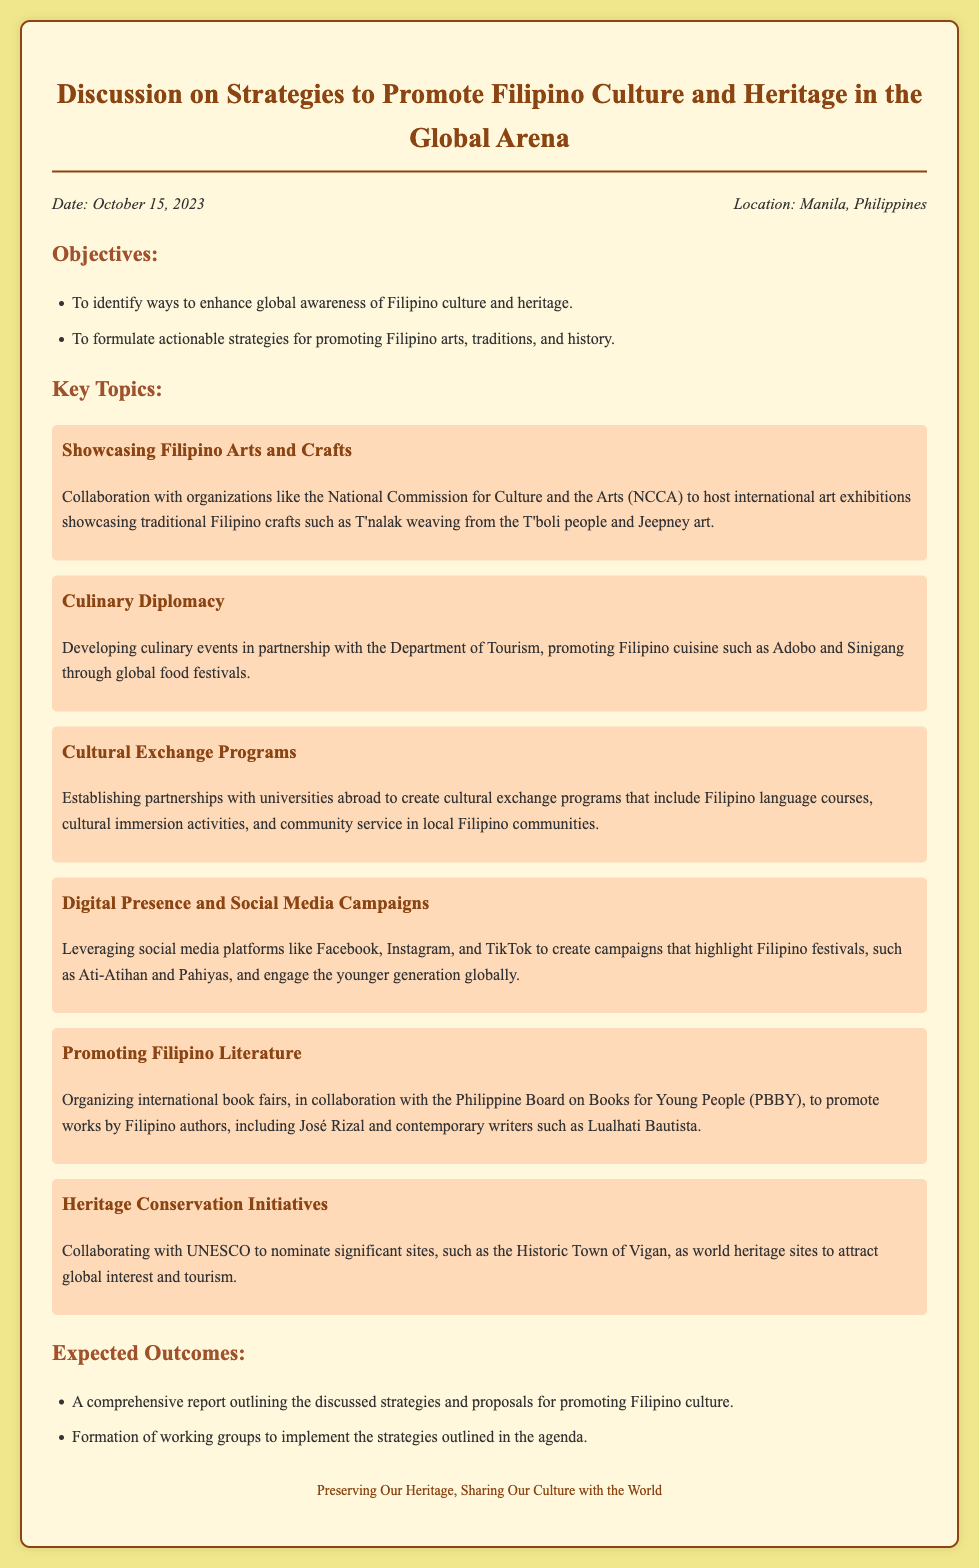What is the date of the discussion? The date of the discussion is explicitly stated in the document.
Answer: October 15, 2023 Where is the location of the event? The location is mentioned in the document under the information section.
Answer: Manila, Philippines What is one of the objectives of the discussion? One of the objectives is outlined in the objectives section of the document.
Answer: To identify ways to enhance global awareness of Filipino culture and heritage Which organization is mentioned for collaboration in showcasing arts? The collaboration with this organization is specified in the key topics section.
Answer: National Commission for Culture and the Arts (NCCA) Name one Filipino dish promoted through culinary diplomacy. This is listed in the culinary diplomacy topic of the document.
Answer: Adobo What is one expected outcome of the discussion? The expected outcomes are clearly outlined in the document.
Answer: A comprehensive report outlining the discussed strategies and proposals for promoting Filipino culture What type of programs does the document suggest for cultural exchange? This is detailed in the cultural exchange programs topic.
Answer: Establishing partnerships with universities abroad How does the document suggest promoting Filipino festivals? This method is specified in the digital presence and social media campaigns topic.
Answer: Leveraging social media platforms Which significant site is mentioned for heritage conservation? A specific site is listed in the heritage conservation initiatives section.
Answer: Historic Town of Vigan 